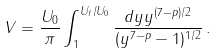<formula> <loc_0><loc_0><loc_500><loc_500>V = \frac { U _ { 0 } } { \pi } \int _ { 1 } ^ { U _ { f } / U _ { 0 } } \frac { d y y ^ { ( 7 - p ) / 2 } } { ( y ^ { 7 - p } - 1 ) ^ { 1 / 2 } } \, .</formula> 